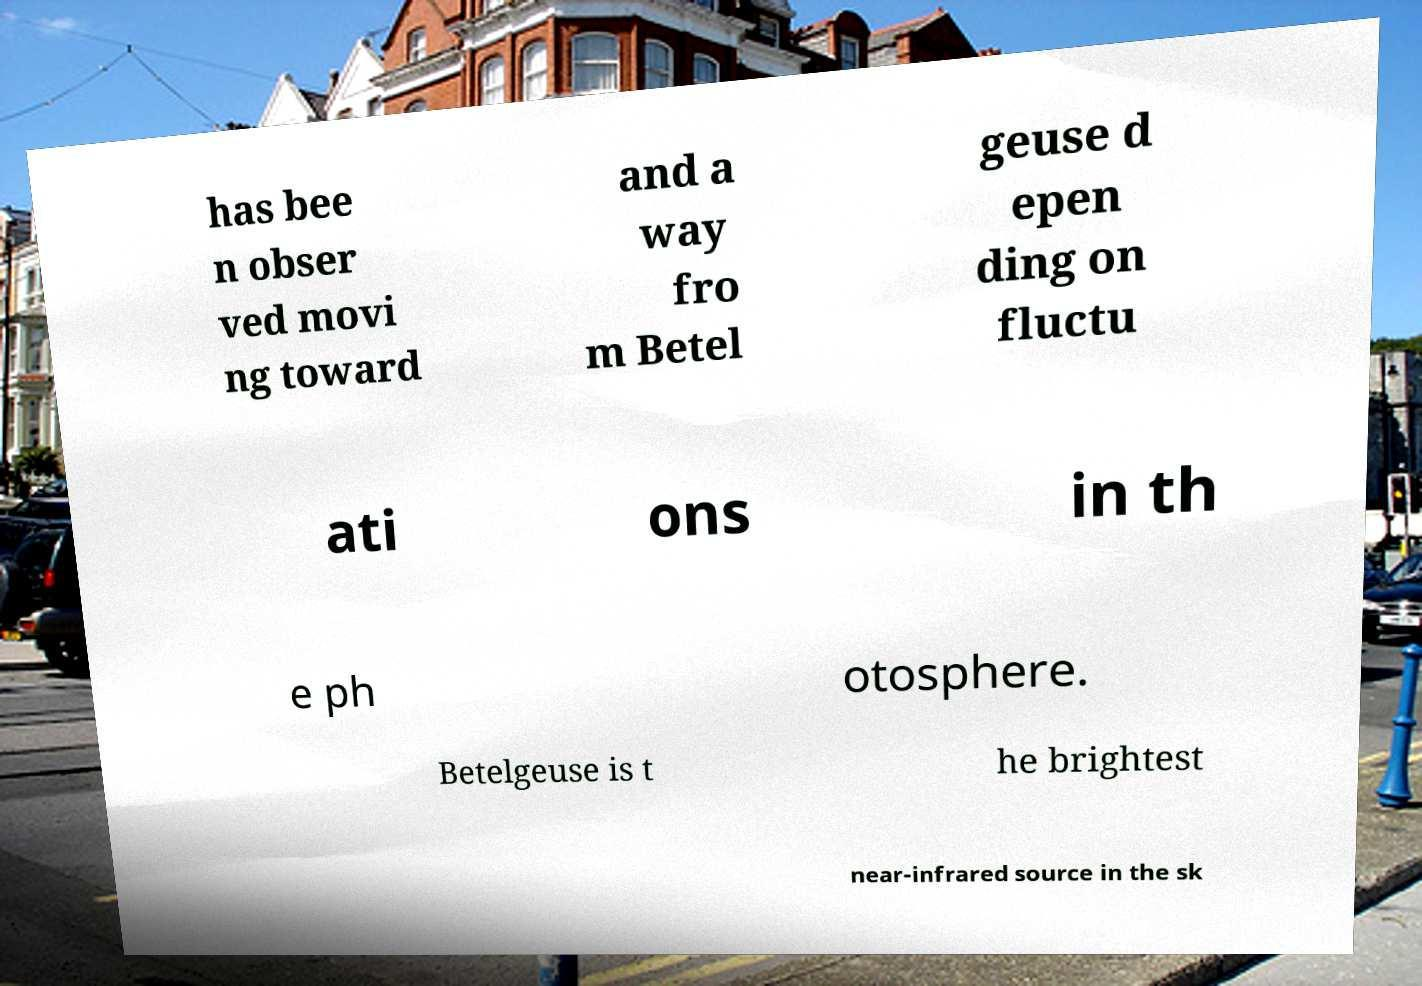Could you assist in decoding the text presented in this image and type it out clearly? has bee n obser ved movi ng toward and a way fro m Betel geuse d epen ding on fluctu ati ons in th e ph otosphere. Betelgeuse is t he brightest near-infrared source in the sk 